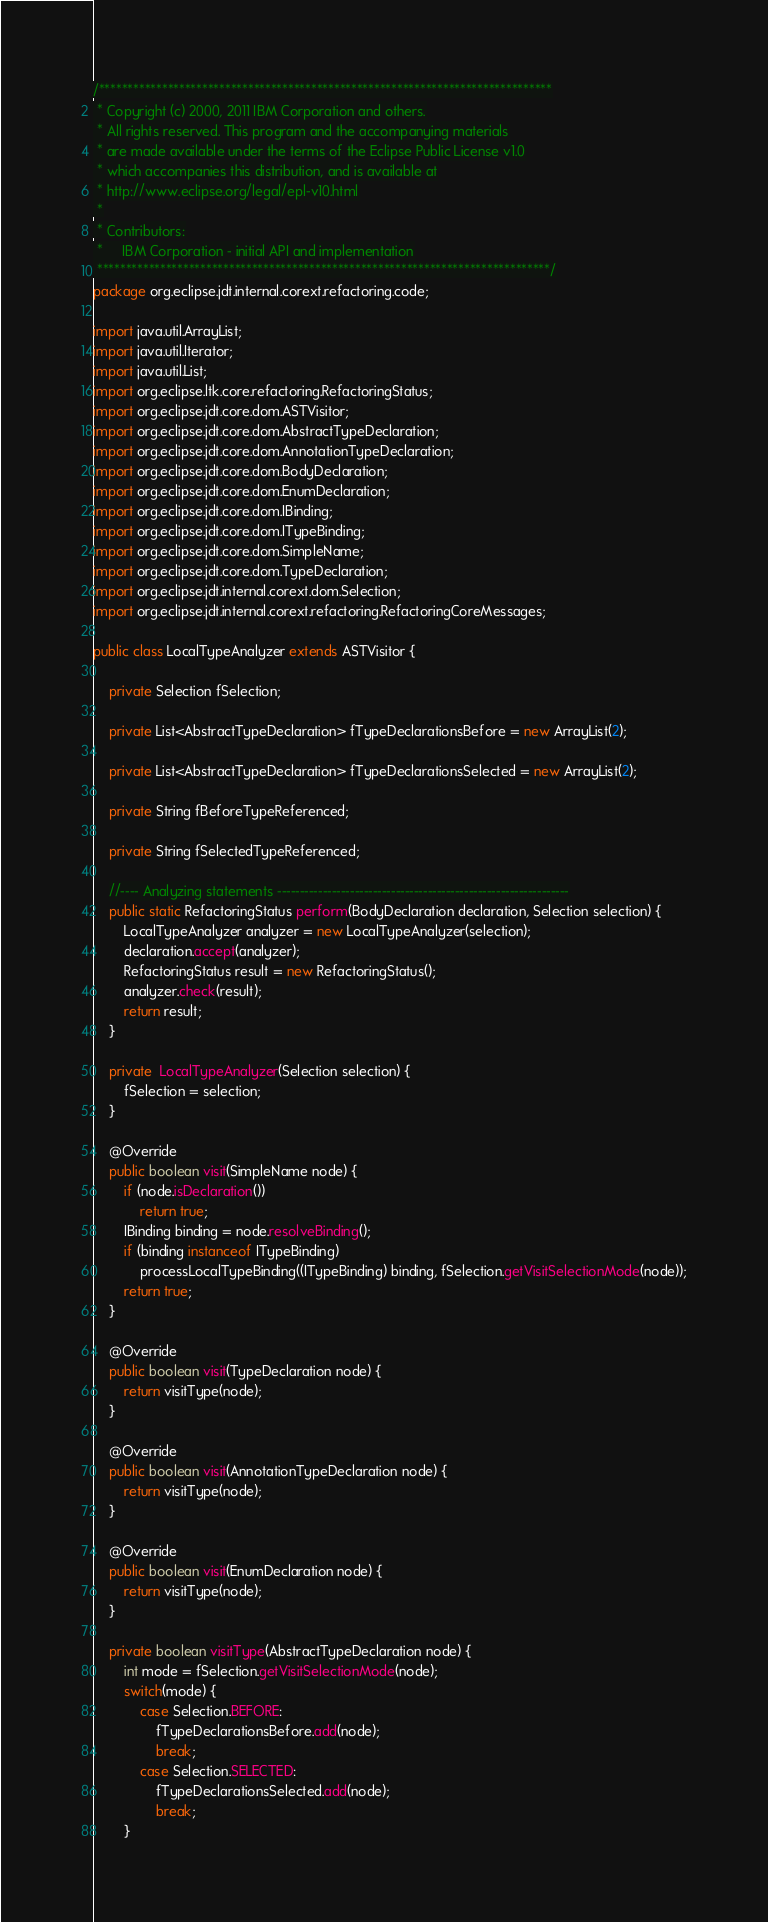Convert code to text. <code><loc_0><loc_0><loc_500><loc_500><_Java_>/*******************************************************************************
 * Copyright (c) 2000, 2011 IBM Corporation and others.
 * All rights reserved. This program and the accompanying materials
 * are made available under the terms of the Eclipse Public License v1.0
 * which accompanies this distribution, and is available at
 * http://www.eclipse.org/legal/epl-v10.html
 *
 * Contributors:
 *     IBM Corporation - initial API and implementation
 *******************************************************************************/
package org.eclipse.jdt.internal.corext.refactoring.code;

import java.util.ArrayList;
import java.util.Iterator;
import java.util.List;
import org.eclipse.ltk.core.refactoring.RefactoringStatus;
import org.eclipse.jdt.core.dom.ASTVisitor;
import org.eclipse.jdt.core.dom.AbstractTypeDeclaration;
import org.eclipse.jdt.core.dom.AnnotationTypeDeclaration;
import org.eclipse.jdt.core.dom.BodyDeclaration;
import org.eclipse.jdt.core.dom.EnumDeclaration;
import org.eclipse.jdt.core.dom.IBinding;
import org.eclipse.jdt.core.dom.ITypeBinding;
import org.eclipse.jdt.core.dom.SimpleName;
import org.eclipse.jdt.core.dom.TypeDeclaration;
import org.eclipse.jdt.internal.corext.dom.Selection;
import org.eclipse.jdt.internal.corext.refactoring.RefactoringCoreMessages;

public class LocalTypeAnalyzer extends ASTVisitor {

    private Selection fSelection;

    private List<AbstractTypeDeclaration> fTypeDeclarationsBefore = new ArrayList(2);

    private List<AbstractTypeDeclaration> fTypeDeclarationsSelected = new ArrayList(2);

    private String fBeforeTypeReferenced;

    private String fSelectedTypeReferenced;

    //---- Analyzing statements ----------------------------------------------------------------
    public static RefactoringStatus perform(BodyDeclaration declaration, Selection selection) {
        LocalTypeAnalyzer analyzer = new LocalTypeAnalyzer(selection);
        declaration.accept(analyzer);
        RefactoringStatus result = new RefactoringStatus();
        analyzer.check(result);
        return result;
    }

    private  LocalTypeAnalyzer(Selection selection) {
        fSelection = selection;
    }

    @Override
    public boolean visit(SimpleName node) {
        if (node.isDeclaration())
            return true;
        IBinding binding = node.resolveBinding();
        if (binding instanceof ITypeBinding)
            processLocalTypeBinding((ITypeBinding) binding, fSelection.getVisitSelectionMode(node));
        return true;
    }

    @Override
    public boolean visit(TypeDeclaration node) {
        return visitType(node);
    }

    @Override
    public boolean visit(AnnotationTypeDeclaration node) {
        return visitType(node);
    }

    @Override
    public boolean visit(EnumDeclaration node) {
        return visitType(node);
    }

    private boolean visitType(AbstractTypeDeclaration node) {
        int mode = fSelection.getVisitSelectionMode(node);
        switch(mode) {
            case Selection.BEFORE:
                fTypeDeclarationsBefore.add(node);
                break;
            case Selection.SELECTED:
                fTypeDeclarationsSelected.add(node);
                break;
        }</code> 